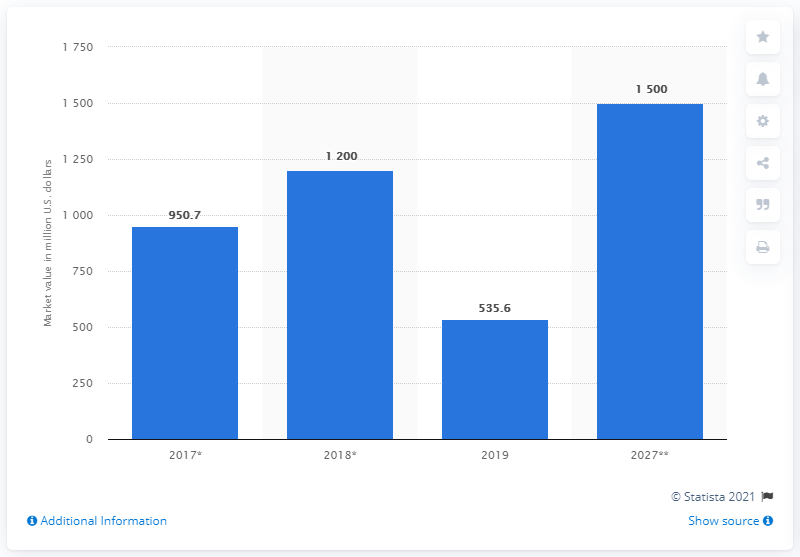Give some essential details in this illustration. The market value of polylactic acid in 2019 was estimated to be $535.6 million. The market value of polylactic acid is expected to be approximately 1500 in 2027. 